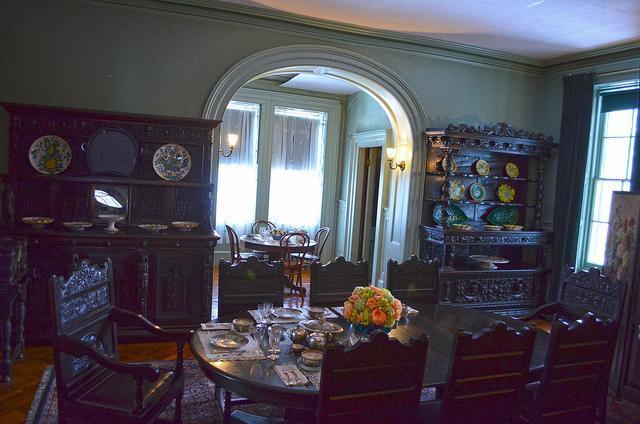How many tables are in the picture?
Give a very brief answer. 2. How many chairs are there?
Give a very brief answer. 8. 